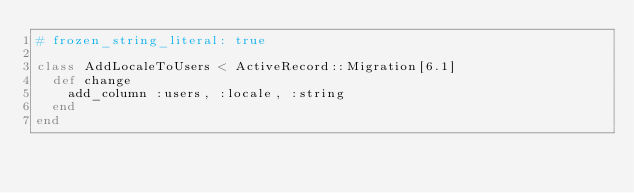Convert code to text. <code><loc_0><loc_0><loc_500><loc_500><_Ruby_># frozen_string_literal: true

class AddLocaleToUsers < ActiveRecord::Migration[6.1]
  def change
    add_column :users, :locale, :string
  end
end
</code> 